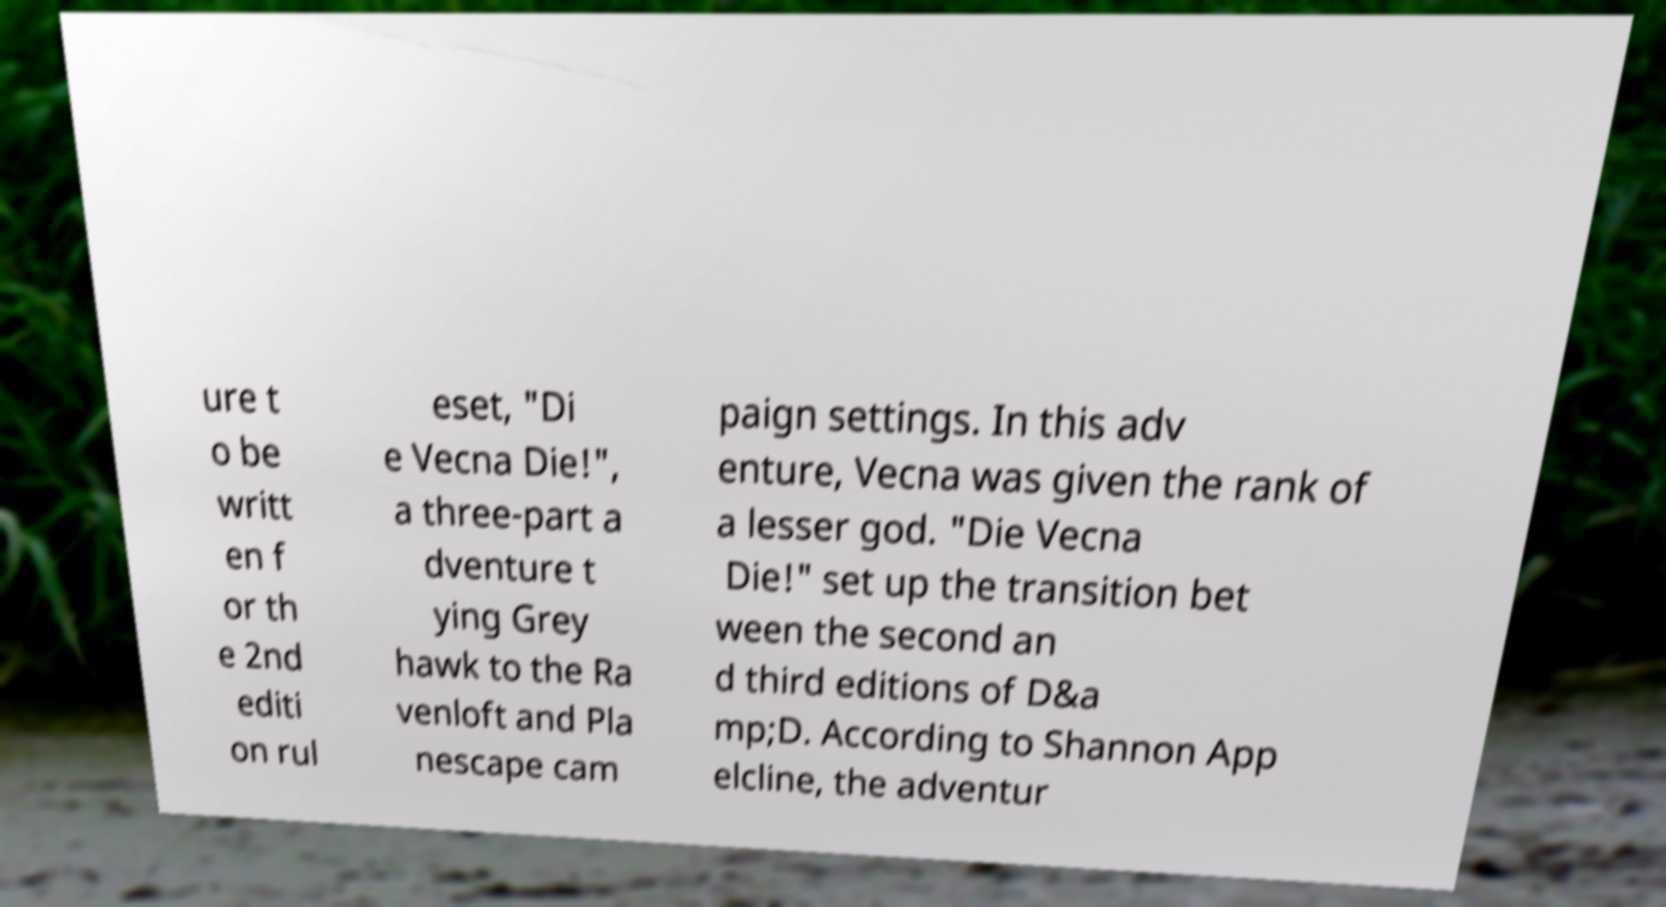What messages or text are displayed in this image? I need them in a readable, typed format. ure t o be writt en f or th e 2nd editi on rul eset, "Di e Vecna Die!", a three-part a dventure t ying Grey hawk to the Ra venloft and Pla nescape cam paign settings. In this adv enture, Vecna was given the rank of a lesser god. "Die Vecna Die!" set up the transition bet ween the second an d third editions of D&a mp;D. According to Shannon App elcline, the adventur 